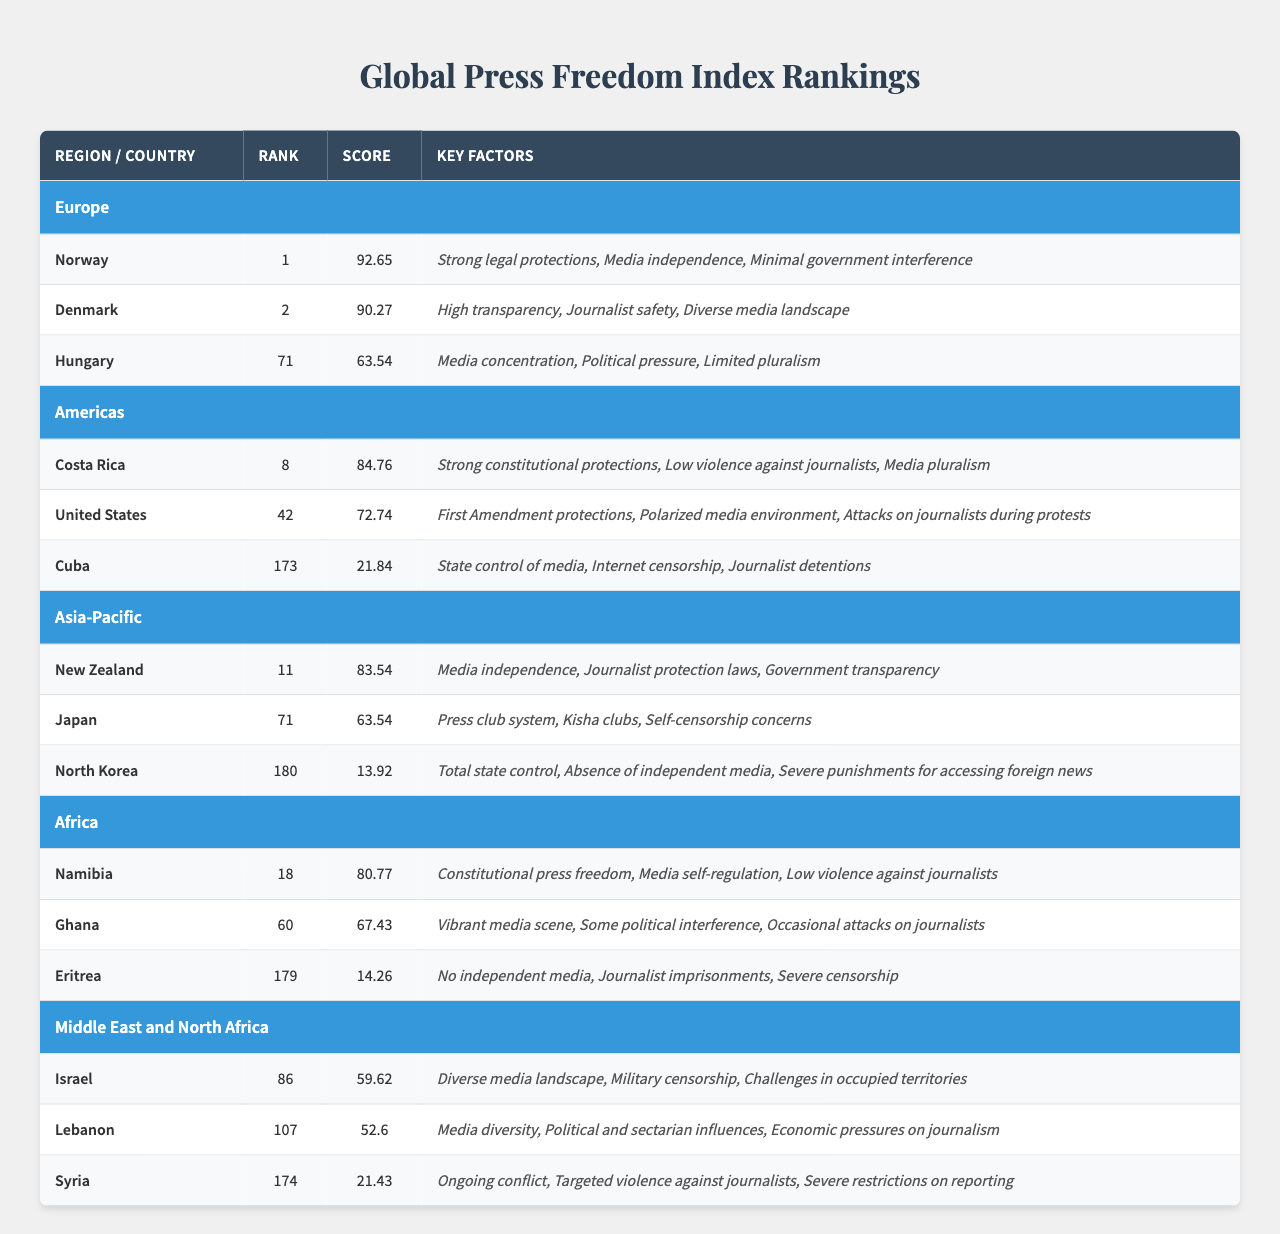What is the highest-ranked country in Europe according to the table? Norway is listed in the Europe region with a rank of 1, making it the highest-ranked country in that region.
Answer: Norway What is the score of Cuba in the Americas region? According to the table, Cuba has a score of 21.84, which is stated next to its rank of 173 in the Americas region.
Answer: 21.84 Which region has the lowest-ranked country, and what is that country's rank? The table shows that North Korea has the lowest rank at 180 in the Asia-Pacific region. This information is gathered by comparing the ranks across all countries in the table.
Answer: Asia-Pacific, 180 Is Denmark ranked higher than the United States? Yes, Denmark is ranked 2 while the United States is ranked 42 in the Americas region, indicating that Denmark has a higher rank.
Answer: Yes What is the average score of the countries listed in the Africa region? The scores of Namibia (80.77), Ghana (67.43), and Eritrea (14.26) are averaged as follows: (80.77 + 67.43 + 14.26) / 3 = 54.82.
Answer: 54.82 Identify two key factors contributing to Japan's press freedom issues mentioned in the table. The table states that Japan faces issues like the press club system and self-censorship concerns, which are listed as key factors affecting its press freedom.
Answer: Press club system, self-censorship Which country in the Middle East and North Africa region has a higher score, Lebanon or Syria? Lebanon has a score of 52.6, while Syria's score is 21.43. Comparing these values shows that Lebanon has the higher score.
Answer: Lebanon How does the score of North Korea compare to that of Hungary? North Korea has a score of 13.92, and Hungary has a score of 63.54. Comparing these values clearly indicates that North Korea's score is significantly lower than Hungary's.
Answer: North Korea is lower What are the key factors that contribute to Costa Rica's relatively high ranking? Costa Rica is described with key factors such as strong constitutional protections, low violence against journalists, and media pluralism, contributing to its relatively high ranking of 8 in the Americas region.
Answer: Strong constitutional protections, low violence, media pluralism Is there a significant difference between the scores of Namibia and Ghana? Yes, the difference in scores is 80.77 (Namibia) - 67.43 (Ghana) = 13.34, indicating a significant difference.
Answer: Yes, 13.34 